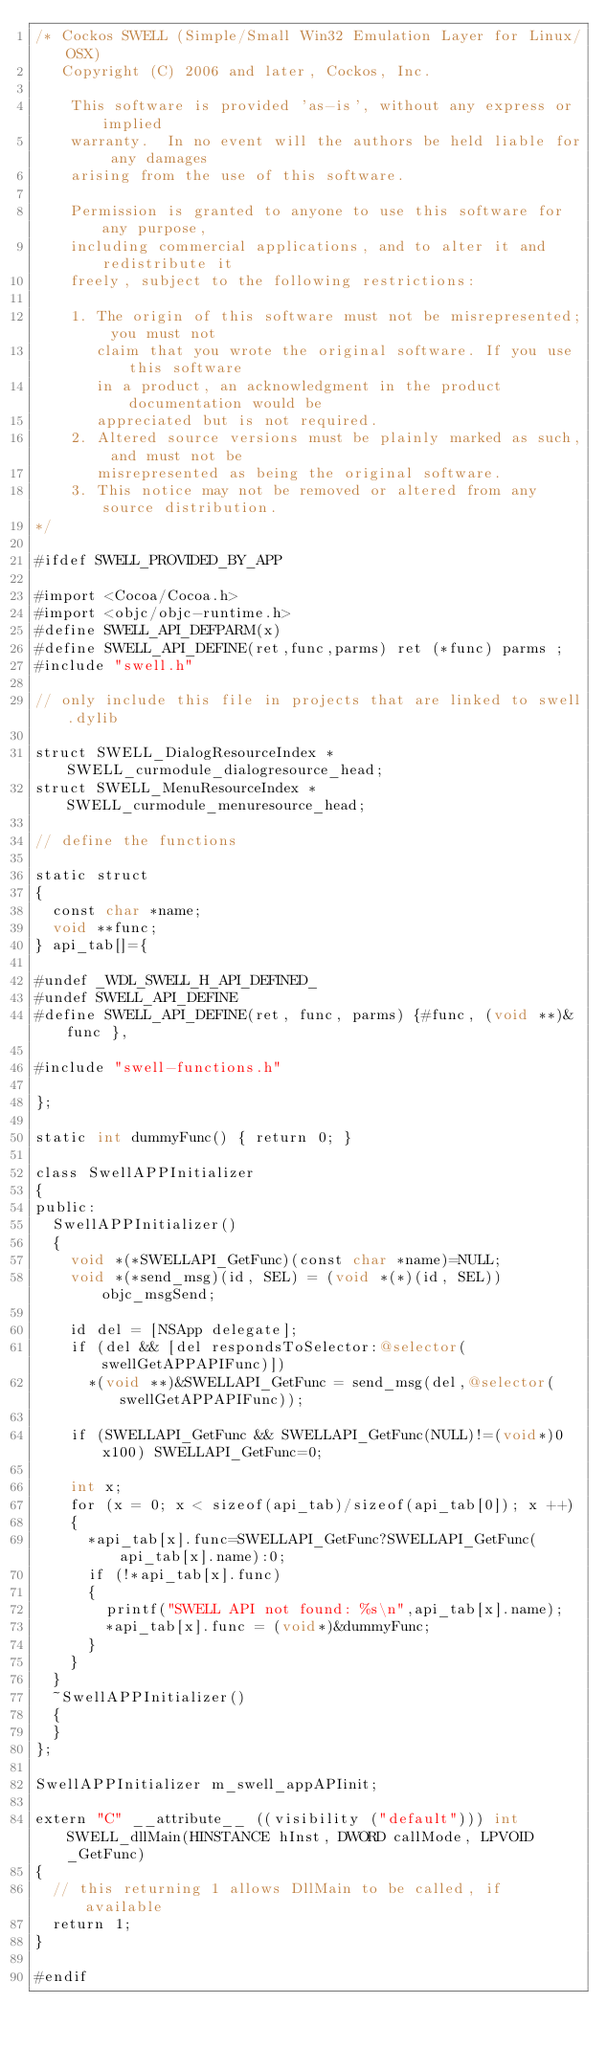Convert code to text. <code><loc_0><loc_0><loc_500><loc_500><_ObjectiveC_>/* Cockos SWELL (Simple/Small Win32 Emulation Layer for Linux/OSX)
   Copyright (C) 2006 and later, Cockos, Inc.

    This software is provided 'as-is', without any express or implied
    warranty.  In no event will the authors be held liable for any damages
    arising from the use of this software.

    Permission is granted to anyone to use this software for any purpose,
    including commercial applications, and to alter it and redistribute it
    freely, subject to the following restrictions:

    1. The origin of this software must not be misrepresented; you must not
       claim that you wrote the original software. If you use this software
       in a product, an acknowledgment in the product documentation would be
       appreciated but is not required.
    2. Altered source versions must be plainly marked as such, and must not be
       misrepresented as being the original software.
    3. This notice may not be removed or altered from any source distribution.
*/
  
#ifdef SWELL_PROVIDED_BY_APP

#import <Cocoa/Cocoa.h>
#import <objc/objc-runtime.h>
#define SWELL_API_DEFPARM(x)
#define SWELL_API_DEFINE(ret,func,parms) ret (*func) parms ;
#include "swell.h"

// only include this file in projects that are linked to swell.dylib

struct SWELL_DialogResourceIndex *SWELL_curmodule_dialogresource_head;
struct SWELL_MenuResourceIndex *SWELL_curmodule_menuresource_head;

// define the functions

static struct
{
  const char *name;
  void **func;
} api_tab[]={
  
#undef _WDL_SWELL_H_API_DEFINED_
#undef SWELL_API_DEFINE
#define SWELL_API_DEFINE(ret, func, parms) {#func, (void **)&func },

#include "swell-functions.h"
  
};

static int dummyFunc() { return 0; }

class SwellAPPInitializer
{
public:
  SwellAPPInitializer()
  {
    void *(*SWELLAPI_GetFunc)(const char *name)=NULL;
    void *(*send_msg)(id, SEL) = (void *(*)(id, SEL))objc_msgSend;
    
    id del = [NSApp delegate];
    if (del && [del respondsToSelector:@selector(swellGetAPPAPIFunc)])
      *(void **)&SWELLAPI_GetFunc = send_msg(del,@selector(swellGetAPPAPIFunc));
      
    if (SWELLAPI_GetFunc && SWELLAPI_GetFunc(NULL)!=(void*)0x100) SWELLAPI_GetFunc=0;
      
    int x;
    for (x = 0; x < sizeof(api_tab)/sizeof(api_tab[0]); x ++)
    {
      *api_tab[x].func=SWELLAPI_GetFunc?SWELLAPI_GetFunc(api_tab[x].name):0;
      if (!*api_tab[x].func)
      {
        printf("SWELL API not found: %s\n",api_tab[x].name);
        *api_tab[x].func = (void*)&dummyFunc;
      }
    }
  }
  ~SwellAPPInitializer()
  {
  }
};

SwellAPPInitializer m_swell_appAPIinit;

extern "C" __attribute__ ((visibility ("default"))) int SWELL_dllMain(HINSTANCE hInst, DWORD callMode, LPVOID _GetFunc)
{
  // this returning 1 allows DllMain to be called, if available
  return 1;
}

#endif
</code> 